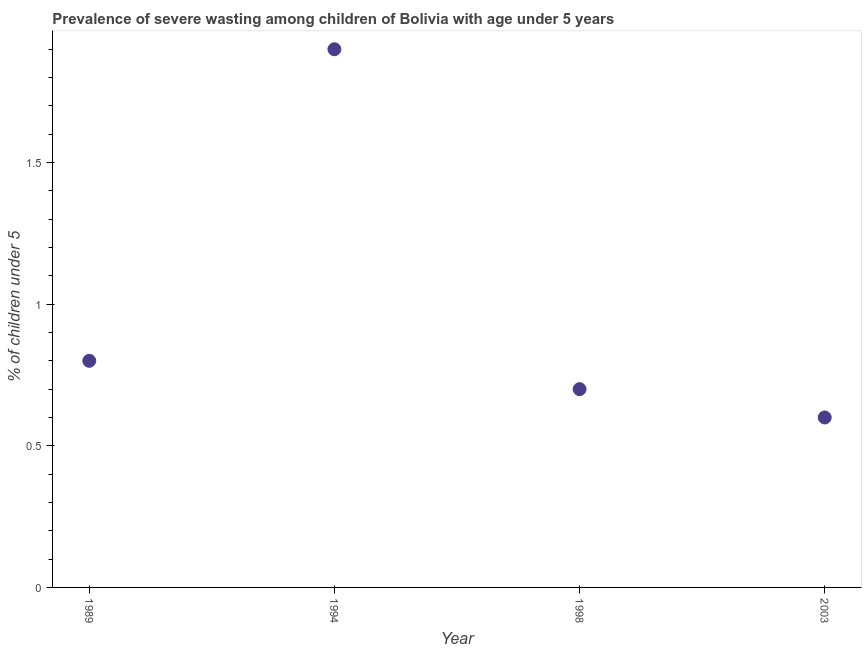What is the prevalence of severe wasting in 1994?
Your response must be concise. 1.9. Across all years, what is the maximum prevalence of severe wasting?
Your response must be concise. 1.9. Across all years, what is the minimum prevalence of severe wasting?
Provide a short and direct response. 0.6. What is the sum of the prevalence of severe wasting?
Provide a succinct answer. 4. What is the difference between the prevalence of severe wasting in 1989 and 2003?
Your response must be concise. 0.2. What is the average prevalence of severe wasting per year?
Your answer should be very brief. 1. What is the median prevalence of severe wasting?
Your answer should be compact. 0.75. Do a majority of the years between 1998 and 1989 (inclusive) have prevalence of severe wasting greater than 0.1 %?
Keep it short and to the point. No. What is the ratio of the prevalence of severe wasting in 1989 to that in 2003?
Your response must be concise. 1.33. Is the prevalence of severe wasting in 1989 less than that in 2003?
Provide a short and direct response. No. Is the difference between the prevalence of severe wasting in 1989 and 2003 greater than the difference between any two years?
Offer a terse response. No. What is the difference between the highest and the second highest prevalence of severe wasting?
Offer a very short reply. 1.1. Is the sum of the prevalence of severe wasting in 1989 and 1998 greater than the maximum prevalence of severe wasting across all years?
Your answer should be compact. No. What is the difference between the highest and the lowest prevalence of severe wasting?
Make the answer very short. 1.3. Does the prevalence of severe wasting monotonically increase over the years?
Offer a terse response. No. How many dotlines are there?
Your answer should be compact. 1. What is the difference between two consecutive major ticks on the Y-axis?
Give a very brief answer. 0.5. Are the values on the major ticks of Y-axis written in scientific E-notation?
Give a very brief answer. No. Does the graph contain grids?
Offer a terse response. No. What is the title of the graph?
Ensure brevity in your answer.  Prevalence of severe wasting among children of Bolivia with age under 5 years. What is the label or title of the X-axis?
Your response must be concise. Year. What is the label or title of the Y-axis?
Give a very brief answer.  % of children under 5. What is the  % of children under 5 in 1989?
Your response must be concise. 0.8. What is the  % of children under 5 in 1994?
Ensure brevity in your answer.  1.9. What is the  % of children under 5 in 1998?
Your answer should be compact. 0.7. What is the  % of children under 5 in 2003?
Offer a very short reply. 0.6. What is the difference between the  % of children under 5 in 1989 and 1998?
Keep it short and to the point. 0.1. What is the difference between the  % of children under 5 in 1998 and 2003?
Offer a very short reply. 0.1. What is the ratio of the  % of children under 5 in 1989 to that in 1994?
Your answer should be compact. 0.42. What is the ratio of the  % of children under 5 in 1989 to that in 1998?
Offer a terse response. 1.14. What is the ratio of the  % of children under 5 in 1989 to that in 2003?
Offer a very short reply. 1.33. What is the ratio of the  % of children under 5 in 1994 to that in 1998?
Keep it short and to the point. 2.71. What is the ratio of the  % of children under 5 in 1994 to that in 2003?
Offer a terse response. 3.17. What is the ratio of the  % of children under 5 in 1998 to that in 2003?
Give a very brief answer. 1.17. 